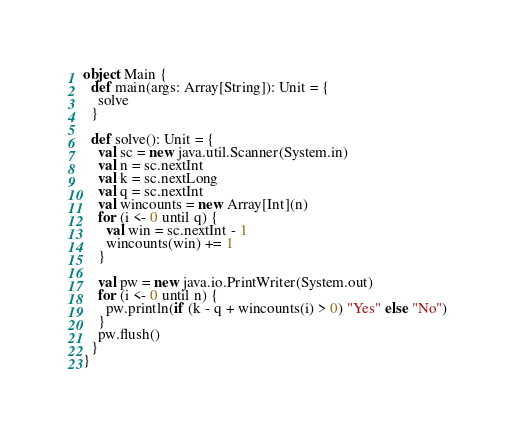<code> <loc_0><loc_0><loc_500><loc_500><_Scala_>object Main {
  def main(args: Array[String]): Unit = {
    solve
  }

  def solve(): Unit = {
    val sc = new java.util.Scanner(System.in)
    val n = sc.nextInt
    val k = sc.nextLong
    val q = sc.nextInt
    val wincounts = new Array[Int](n)
    for (i <- 0 until q) {
      val win = sc.nextInt - 1
      wincounts(win) += 1
    }

    val pw = new java.io.PrintWriter(System.out)
    for (i <- 0 until n) {
      pw.println(if (k - q + wincounts(i) > 0) "Yes" else "No")
    }
    pw.flush()
  }
}
</code> 